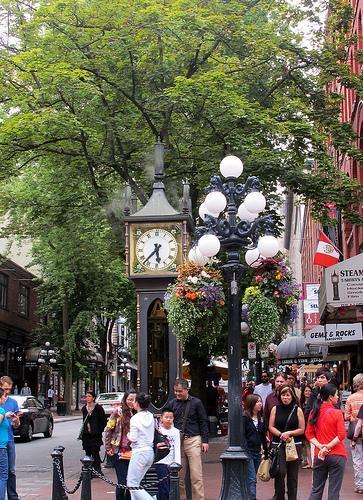How many clocks are shown?
Give a very brief answer. 1. 